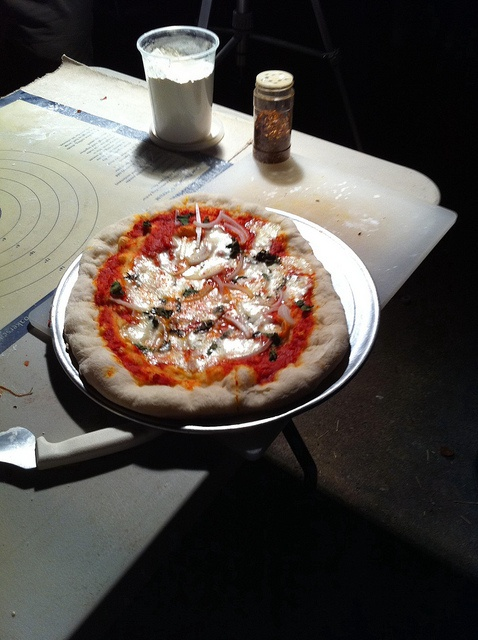Describe the objects in this image and their specific colors. I can see dining table in black, lightgray, gray, and darkgray tones, pizza in black, darkgray, brown, white, and gray tones, cup in black, gray, white, and darkgray tones, knife in black, darkgray, white, and gray tones, and bottle in black, maroon, and beige tones in this image. 